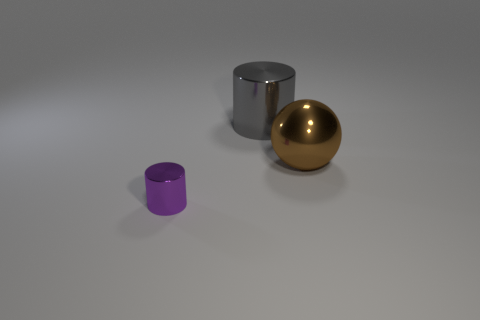Is there any other thing that has the same size as the purple cylinder?
Your response must be concise. No. What is the color of the shiny thing that is in front of the big metal thing right of the gray metal object?
Your response must be concise. Purple. How many green matte spheres are there?
Offer a very short reply. 0. What number of metal objects are to the left of the metallic sphere and right of the small purple metallic thing?
Keep it short and to the point. 1. Are there any other things that are the same shape as the brown thing?
Your answer should be very brief. No. There is a small metallic thing; is it the same color as the cylinder that is right of the purple object?
Provide a short and direct response. No. The object that is on the left side of the gray metal cylinder has what shape?
Ensure brevity in your answer.  Cylinder. What is the material of the small purple cylinder?
Your answer should be compact. Metal. What number of large things are gray metal cylinders or brown spheres?
Your answer should be very brief. 2. What number of large metallic objects are behind the brown object?
Keep it short and to the point. 1. 